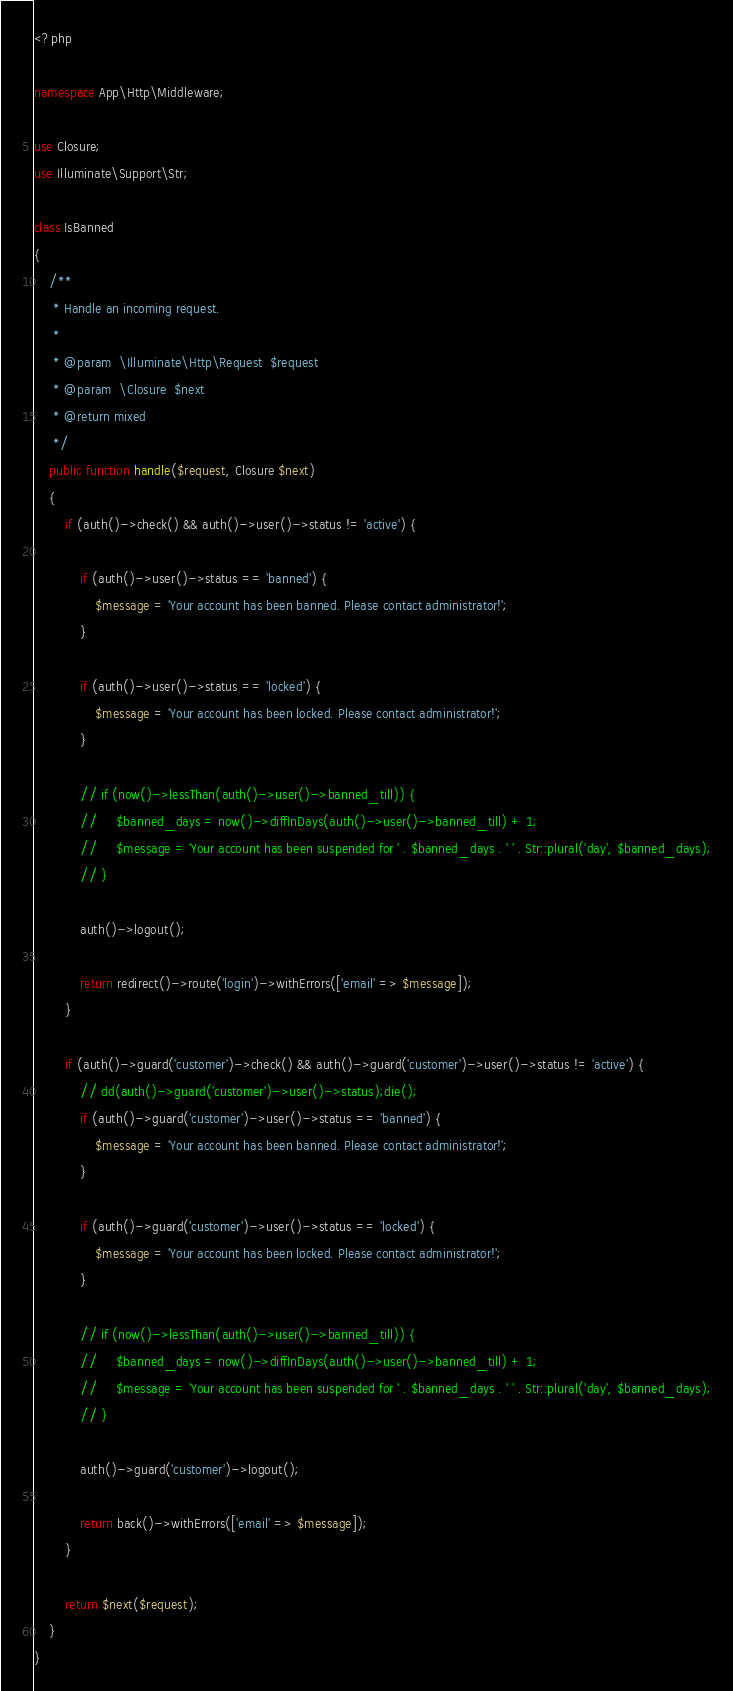Convert code to text. <code><loc_0><loc_0><loc_500><loc_500><_PHP_><?php

namespace App\Http\Middleware;

use Closure;
use Illuminate\Support\Str;

class IsBanned
{
    /**
     * Handle an incoming request.
     *
     * @param  \Illuminate\Http\Request  $request
     * @param  \Closure  $next
     * @return mixed
     */
    public function handle($request, Closure $next)
    {
        if (auth()->check() && auth()->user()->status != 'active') {

            if (auth()->user()->status == 'banned') {
                $message = 'Your account has been banned. Please contact administrator!';
            }

            if (auth()->user()->status == 'locked') {
                $message = 'Your account has been locked. Please contact administrator!';
            }

            // if (now()->lessThan(auth()->user()->banned_till)) {
            //     $banned_days = now()->diffInDays(auth()->user()->banned_till) + 1;
            //     $message = 'Your account has been suspended for ' . $banned_days . ' ' . Str::plural('day', $banned_days);
            // }

            auth()->logout();

            return redirect()->route('login')->withErrors(['email' => $message]);
        }

        if (auth()->guard('customer')->check() && auth()->guard('customer')->user()->status != 'active') {
            // dd(auth()->guard('customer')->user()->status);die();
            if (auth()->guard('customer')->user()->status == 'banned') {
                $message = 'Your account has been banned. Please contact administrator!';
            }

            if (auth()->guard('customer')->user()->status == 'locked') {
                $message = 'Your account has been locked. Please contact administrator!';
            }

            // if (now()->lessThan(auth()->user()->banned_till)) {
            //     $banned_days = now()->diffInDays(auth()->user()->banned_till) + 1;
            //     $message = 'Your account has been suspended for ' . $banned_days . ' ' . Str::plural('day', $banned_days);
            // }
            
            auth()->guard('customer')->logout();

            return back()->withErrors(['email' => $message]);
        }

        return $next($request);
    }
}
</code> 